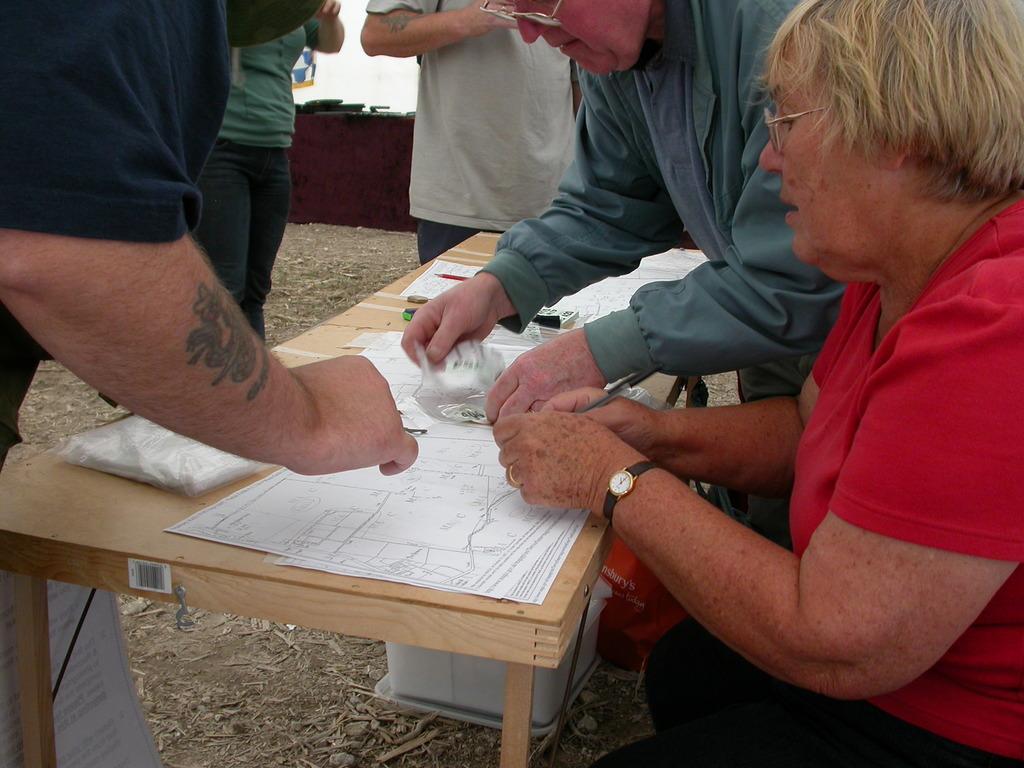Could you give a brief overview of what you see in this image? In this image I can see few people are in front of the table. On the table there are papers. 